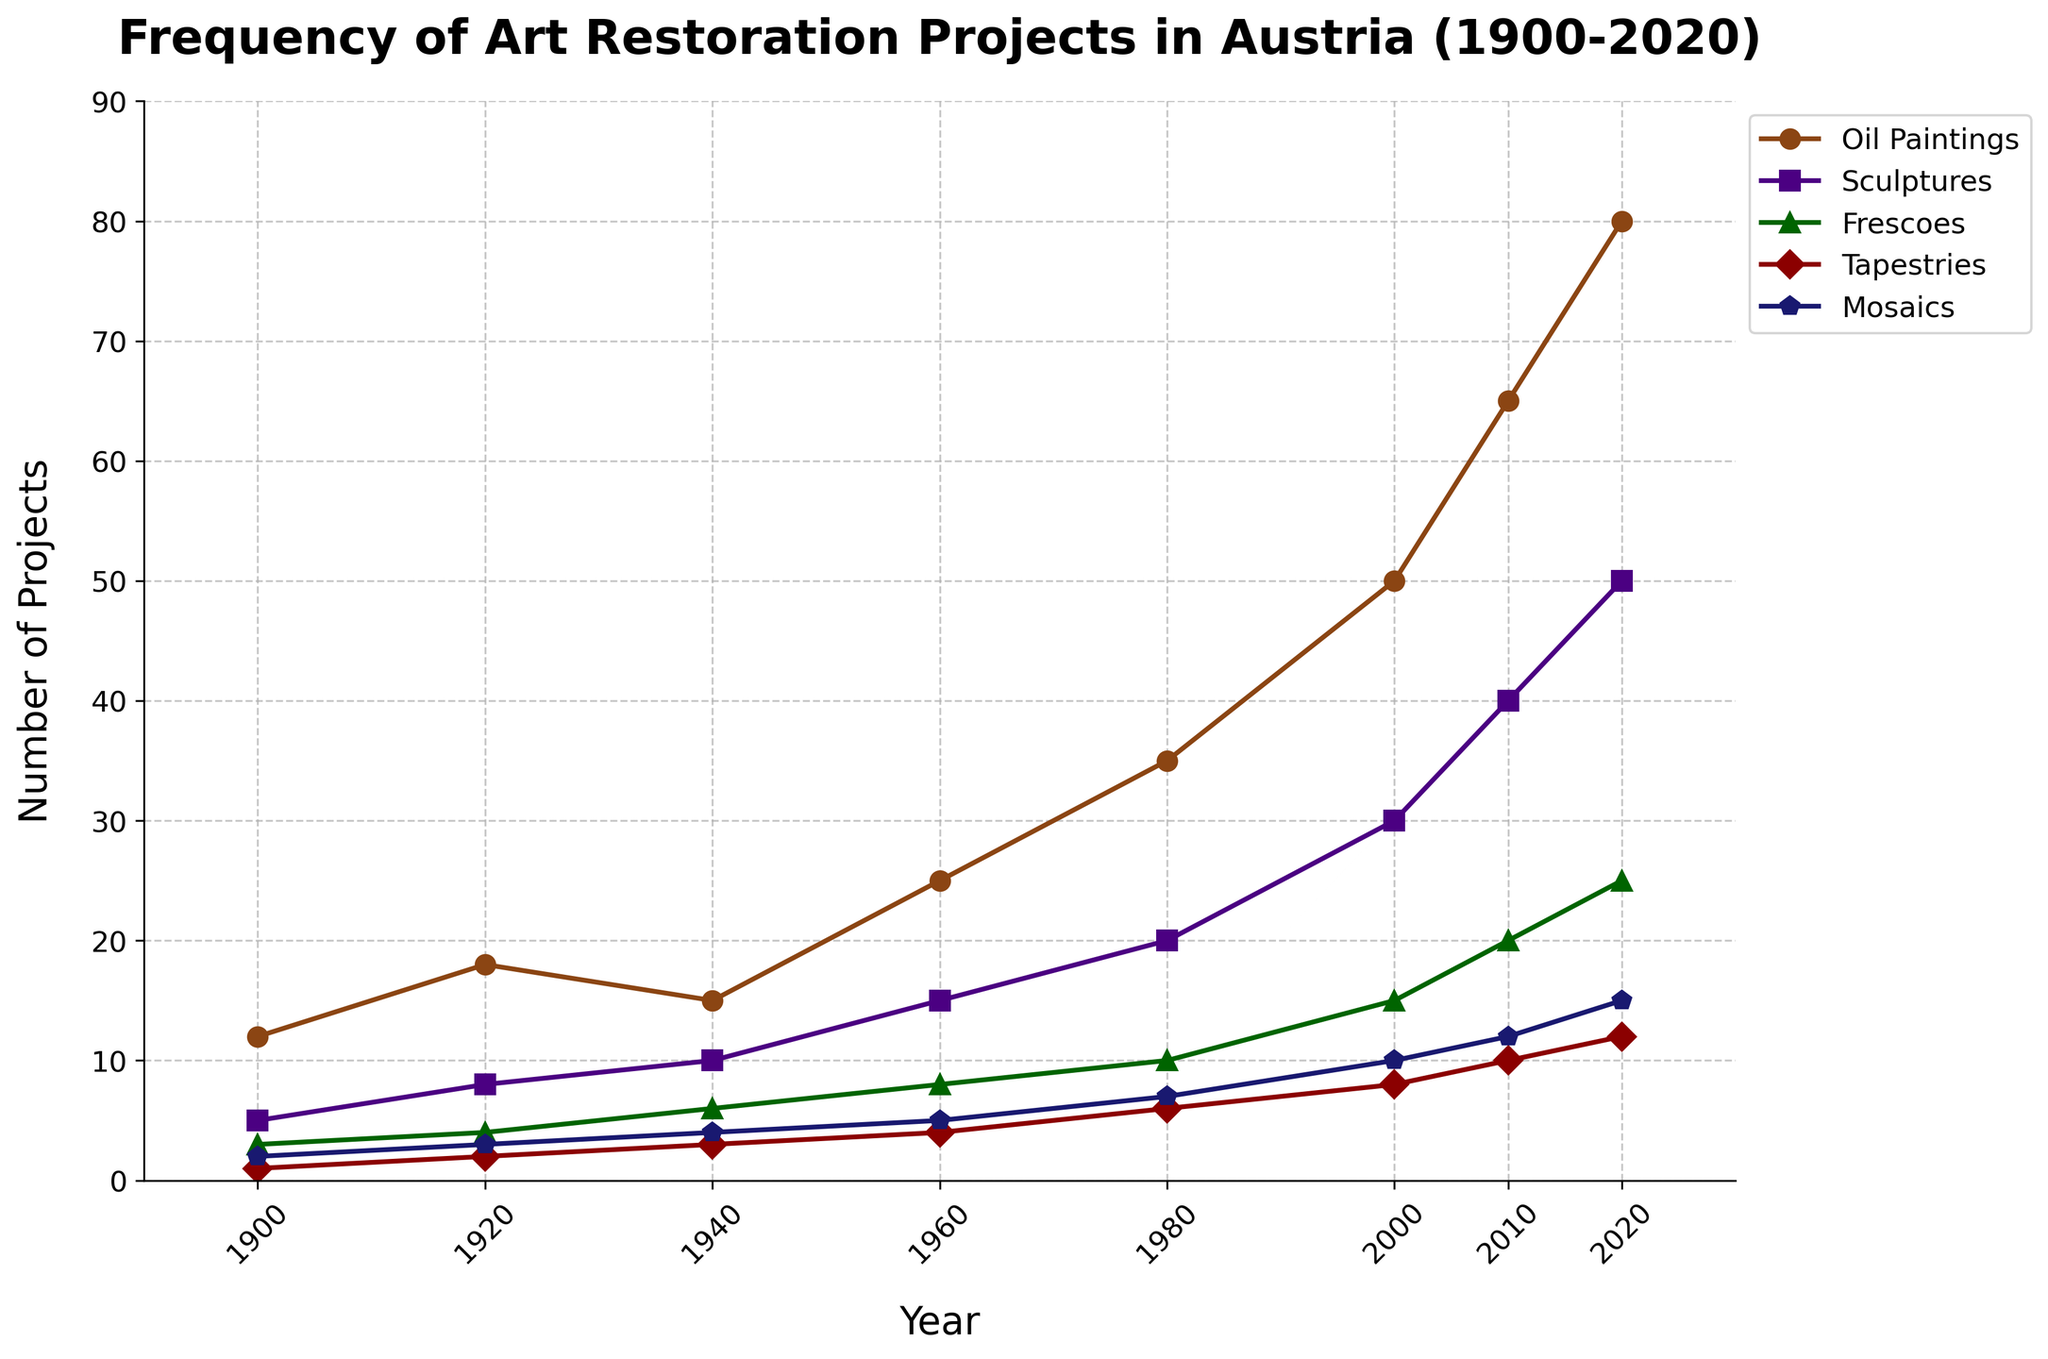How many art restoration projects were conducted for oil paintings and sculptures combined in the year 1920? In the year 1920, there were 18 projects for oil paintings and 8 for sculptures. Adding them together, 18 + 8 equals 26.
Answer: 26 Which artwork medium experienced the greatest increase in the frequency of restoration projects from 1940 to 1960? From 1940 to 1960, the restoration projects for oil paintings increased from 15 to 25, which is an increase of 10. Comparing other mediums (sculptures: 10 to 15, frescoes: 6 to 8, tapestries: 3 to 4, mosaics: 4 to 5), oil paintings had the greatest increase.
Answer: Oil Paintings In 2020, which artwork medium had the fewest restoration projects? In 2020, the number of restoration projects for each medium is: Oil Paintings (80), Sculptures (50), Frescoes (25), Tapestries (12), Mosaics (15). The fewest among them is Tapestries with 12 projects.
Answer: Tapestries What is the total number of restoration projects conducted for frescoes from 1900 to 2020? Summing the number of projects for frescoes over the years 1900, 1920, 1940, 1960, 1980, 2000, 2010, and 2020 results in 3 + 4 + 6 + 8 + 10 + 15 + 20 + 25 = 91.
Answer: 91 Compare the number of restoration projects for tapestries in 1960 and mosaics in 1980. Which had more and by how much? In 1960, there were 4 restoration projects for tapestries. In 1980, there were 7 restoration projects for mosaics. Comparing them, 7 (mosaics) - 4 (tapestries) equals 3. Thus, mosaics had 3 more projects.
Answer: Mosaics by 3 Has the frequency of art restoration projects for oil paintings ever decreased between any two consecutive decades between 1900 and 2020? Observing the frequency of oil paintings from 1900 to 2020: 12, 18, 15, 25, 35, 50, 65, 80 shows a decrease between 1920 and 1940, from 18 to 15.
Answer: Yes, between 1920 and 1940 What was the percentage increase in the number of restoration projects for mosaics from 1980 to 2020? In 1980, there were 7 projects for mosaics, and in 2020 there were 15. The percentage increase is calculated as ((15 - 7) / 7) * 100 = 114.29%.
Answer: 114.29% Which medium saw the steepest increase in restoration projects between 2000 and 2010? Between 2000 and 2010, the restoration projects increased for oil paintings from 50 to 65 (15), sculptures from 30 to 40 (10), frescoes from 15 to 20 (5), tapestries from 8 to 10 (2), and mosaics from 10 to 12 (2). Oil paintings saw the steepest increase of 15.
Answer: Oil Paintings 